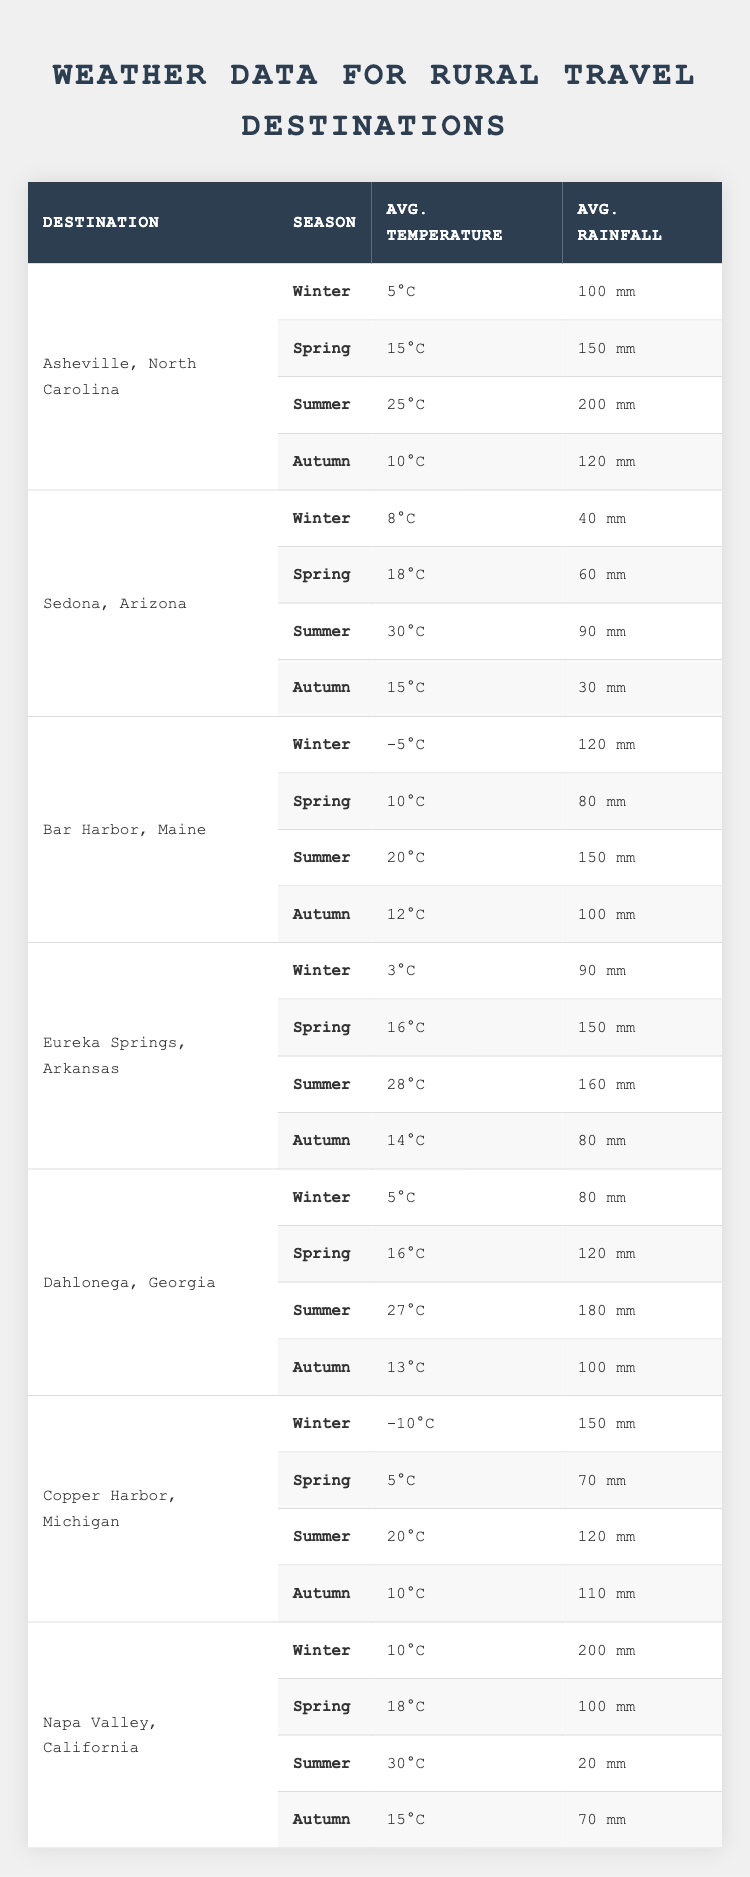What is the average temperature in Sedona, Arizona during Summer? Looking at the row for Sedona, Arizona under Summer, the average temperature is listed as 30°C.
Answer: 30°C What is the average rainfall in Asheville, North Carolina during Winter? In the Winter row for Asheville, North Carolina, the average rainfall is 100 mm.
Answer: 100 mm Which destination has the lowest average temperature in Winter? Comparing the Winter temperatures across all destinations, Copper Harbor, Michigan has the lowest temperature at -10°C.
Answer: Copper Harbor, Michigan What is the total average rainfall across all seasons for Dahlonega, Georgia? Adding the rainfall values for Dahlonega in all seasons: 80 + 120 + 180 + 100 = 480 mm.
Answer: 480 mm Is the average temperature in Bar Harbor, Maine during Autumn higher than in Eureka Springs, Arkansas? Bar Harbor's Autumn temperature is 12°C while Eureka Springs shows 14°C. Since 12°C is less than 14°C, the statement is false.
Answer: No Which destination experiences the highest average rainfall in Summer? Reviews the Summer rainfall data and identifies Eureka Springs, Arkansas with 160 mm as the highest.
Answer: Eureka Springs, Arkansas What is the difference in average rainfall between the Spring and Summer seasons for Napa Valley, California? The Spring rainfall is 100 mm and Summer rainfall is 20 mm. The difference is 100 - 20 = 80 mm.
Answer: 80 mm In which season does Copper Harbor, Michigan have a temperature of 10°C? Looking at Copper Harbor's seasonal temperatures, the temperature of 10°C occurs in Autumn.
Answer: Autumn What city has the most consistent average temperature across seasons? Evaluating temperature variations, Sedona, Arizona has temperatures ranging from 8°C to 30°C, while others have wider ranges indicating more inconsistency. Sedona is the most consistent.
Answer: Sedona, Arizona Is the average winter rainfall in Napa Valley, California greater than that in Asheville, North Carolina? Napa Valley's winter rainfall is 200 mm while Asheville's is 100 mm. Since 200 mm is greater than 100 mm, the statement is true.
Answer: Yes What is the average temperature for all destinations in Summer? The Summer average temperatures are: Asheville 25°C, Sedona 30°C, Bar Harbor 20°C, Eureka Springs 28°C, Dahlonega 27°C, Copper Harbor 20°C, Napa Valley 30°C. Sum these (25 + 30 + 20 + 28 + 27 + 20 + 30 =  210) and divide by 7 (total of 7 destinations): 210/7 = 30°C.
Answer: 30°C 